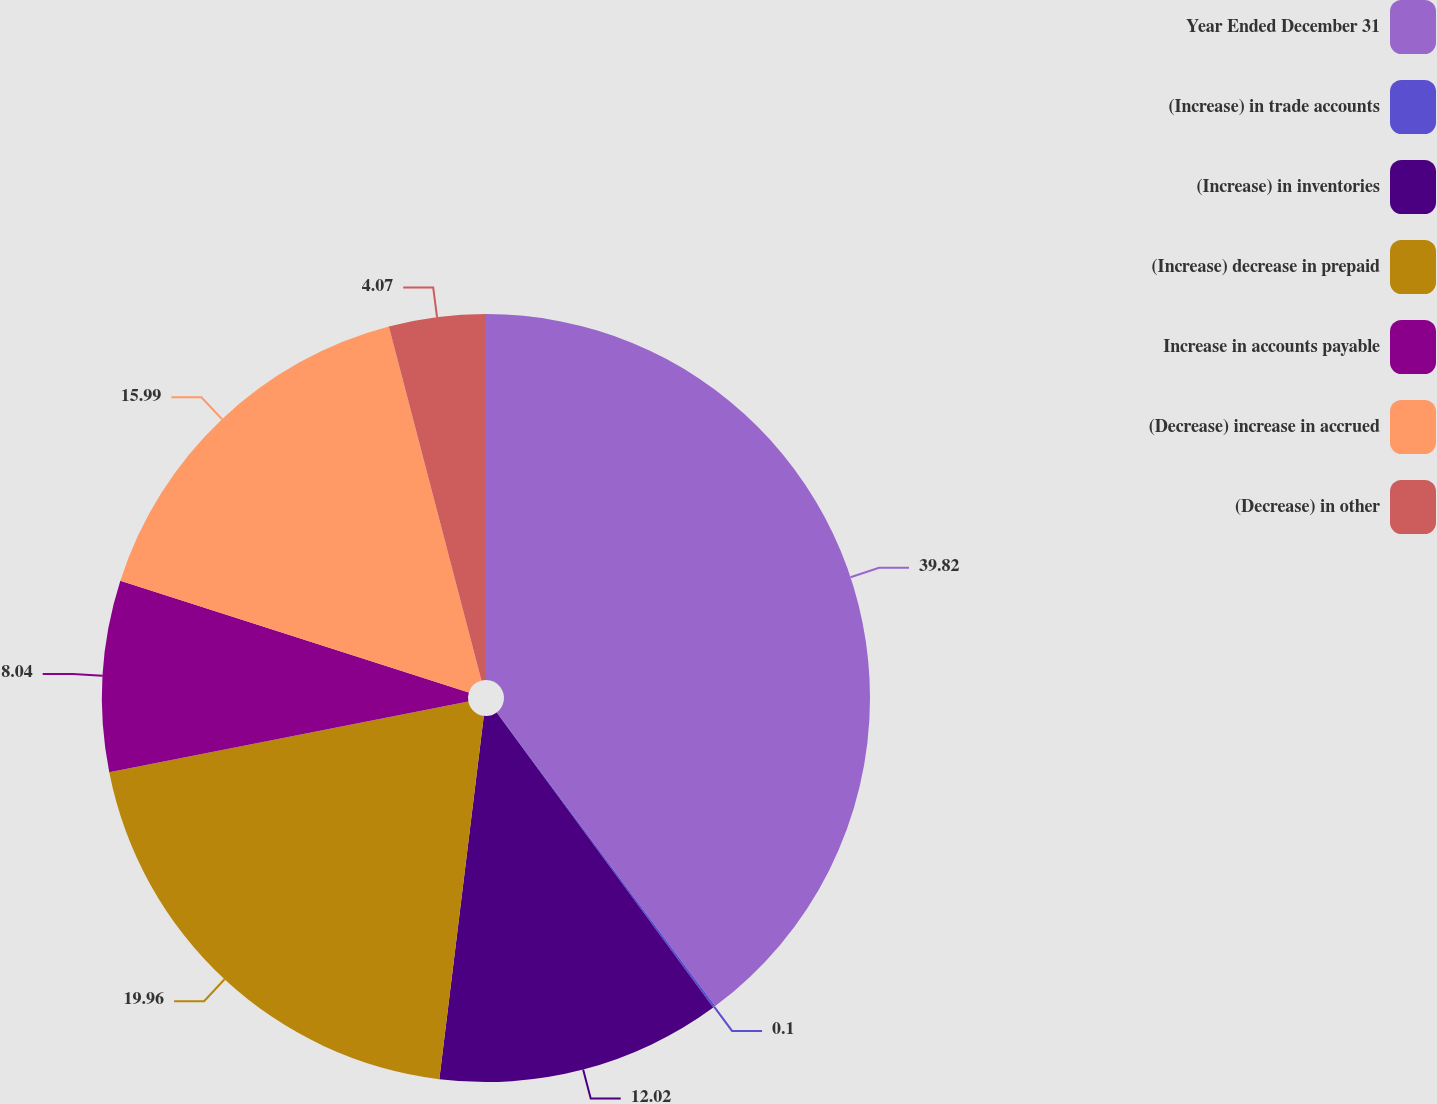Convert chart to OTSL. <chart><loc_0><loc_0><loc_500><loc_500><pie_chart><fcel>Year Ended December 31<fcel>(Increase) in trade accounts<fcel>(Increase) in inventories<fcel>(Increase) decrease in prepaid<fcel>Increase in accounts payable<fcel>(Decrease) increase in accrued<fcel>(Decrease) in other<nl><fcel>39.82%<fcel>0.1%<fcel>12.02%<fcel>19.96%<fcel>8.04%<fcel>15.99%<fcel>4.07%<nl></chart> 